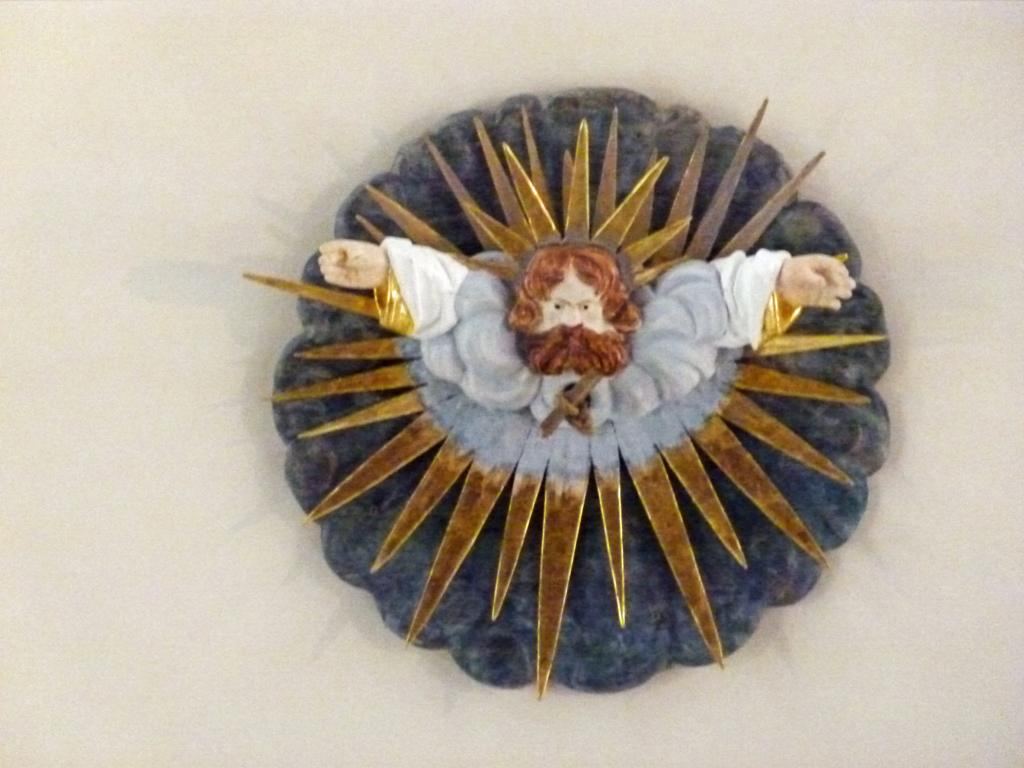What is the main subject in the foreground of the image? There is a sculpture in the foreground of the image. Where is the sculpture located? The sculpture is on a wall. What type of pollution can be seen around the sculpture in the image? There is no pollution visible in the image; it only features a sculpture on a wall. 